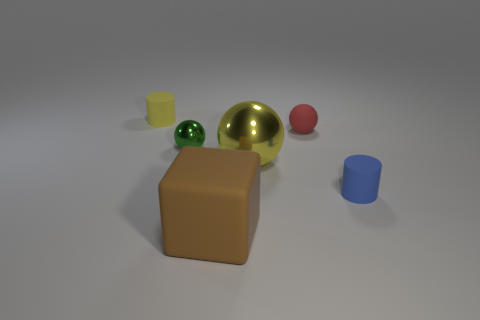Add 3 tiny matte cylinders. How many objects exist? 9 Subtract all red balls. How many balls are left? 2 Subtract all cylinders. How many objects are left? 4 Add 5 big brown matte things. How many big brown matte things are left? 6 Add 1 brown cylinders. How many brown cylinders exist? 1 Subtract 0 red blocks. How many objects are left? 6 Subtract all large blocks. Subtract all tiny yellow things. How many objects are left? 4 